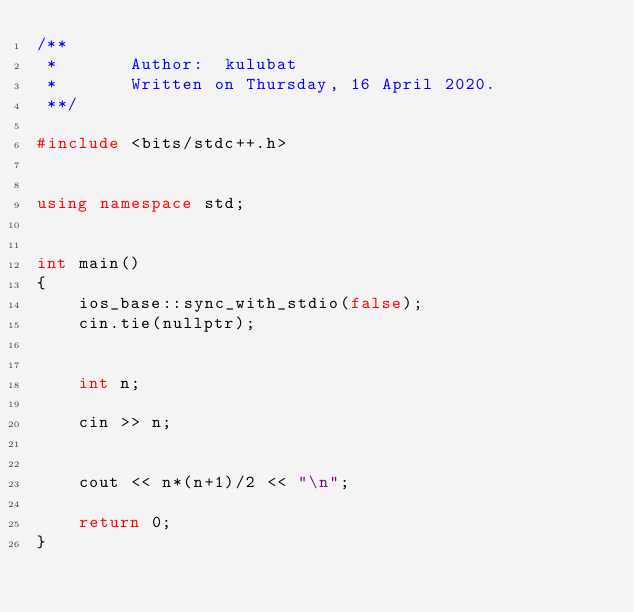<code> <loc_0><loc_0><loc_500><loc_500><_C++_>/**
 *       Author:  kulubat
 *       Written on Thursday, 16 April 2020.
 **/

#include <bits/stdc++.h>


using namespace std;


int main()
{
    ios_base::sync_with_stdio(false);
    cin.tie(nullptr);
    
    
    int n;

    cin >> n;


    cout << n*(n+1)/2 << "\n";

    return 0;
}
</code> 